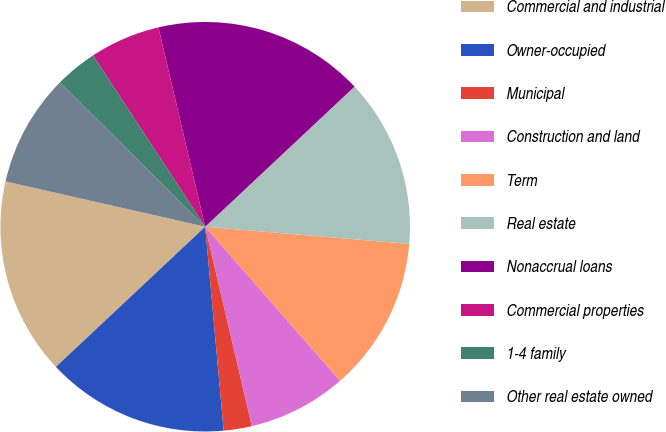Convert chart. <chart><loc_0><loc_0><loc_500><loc_500><pie_chart><fcel>Commercial and industrial<fcel>Owner-occupied<fcel>Municipal<fcel>Construction and land<fcel>Term<fcel>Real estate<fcel>Nonaccrual loans<fcel>Commercial properties<fcel>1-4 family<fcel>Other real estate owned<nl><fcel>15.55%<fcel>14.44%<fcel>2.22%<fcel>7.78%<fcel>12.22%<fcel>13.33%<fcel>16.67%<fcel>5.56%<fcel>3.33%<fcel>8.89%<nl></chart> 